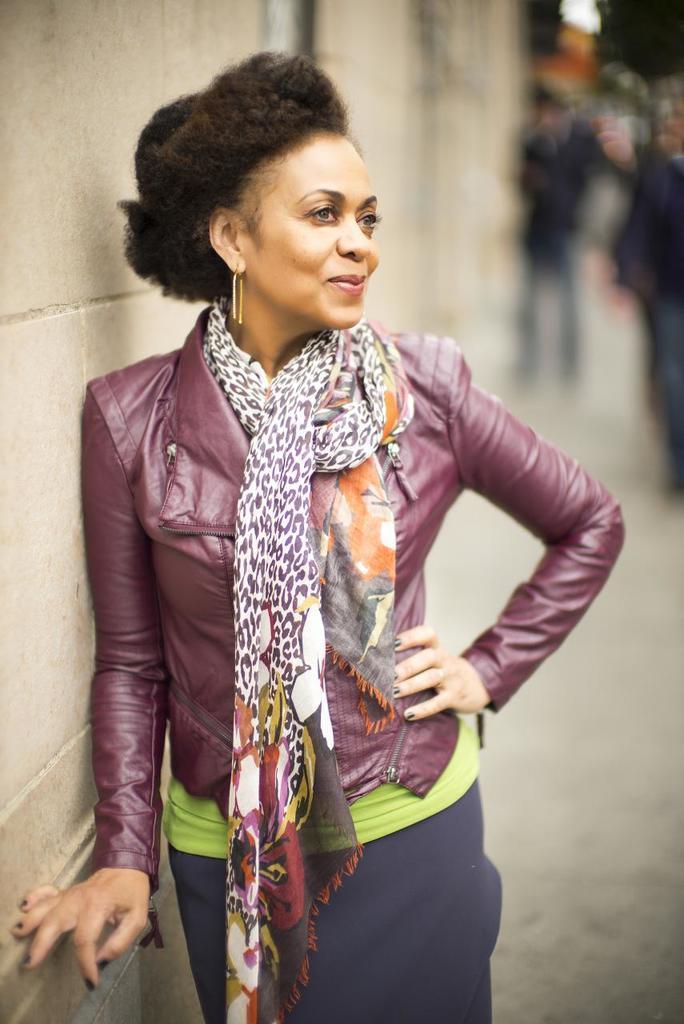Describe this image in one or two sentences. In this picture we can observe a woman standing. There is a wall on the left side. She is smiling. We can observe purple color jacket and a scarf around her neck. In the background there are some people standing. 